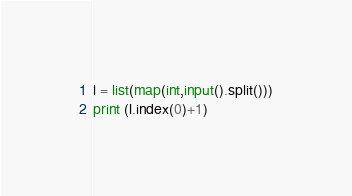Convert code to text. <code><loc_0><loc_0><loc_500><loc_500><_Python_>l = list(map(int,input().split()))
print (l.index(0)+1)
</code> 